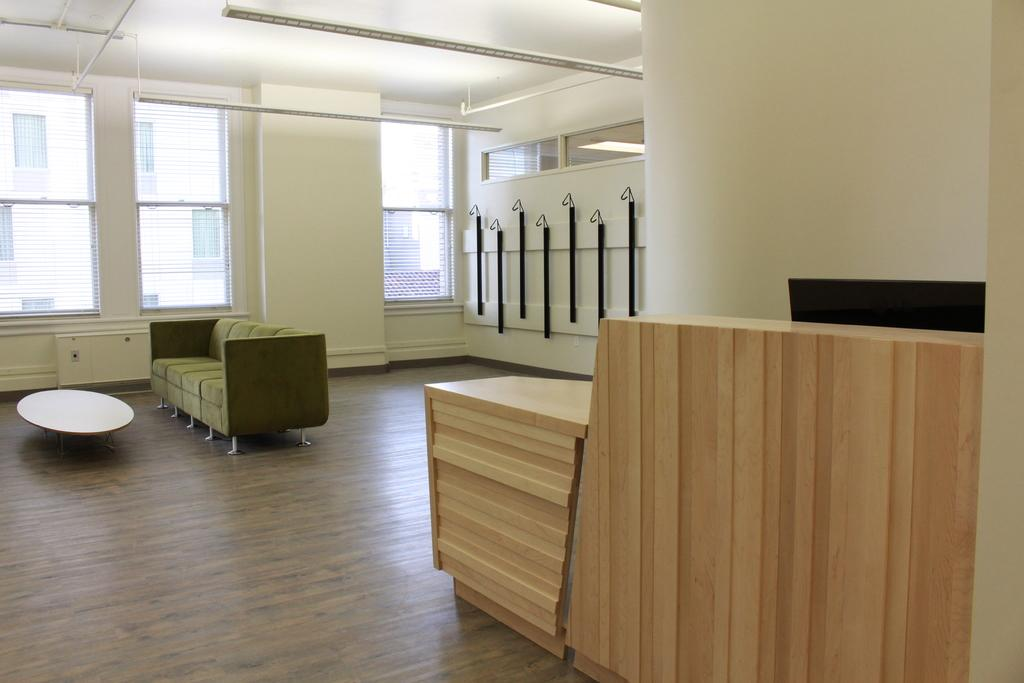What type of space is depicted in the picture? There is a room in the picture. What furniture is present in the room? There is a sofa and a table placed in front of the sofa in the room. What can be used for hanging clothes in the room? There are hangers in the room. What is visible in the background of the room? There is a wall and a window in the background of the room. What type of birthday event is taking place in the room? There is no indication of a birthday event or any event taking place in the room; the image only shows a room with furniture and hangers. How many planes can be seen flying outside the window in the room? There are no planes visible in the image, as it only shows a room with furniture and hangers. 